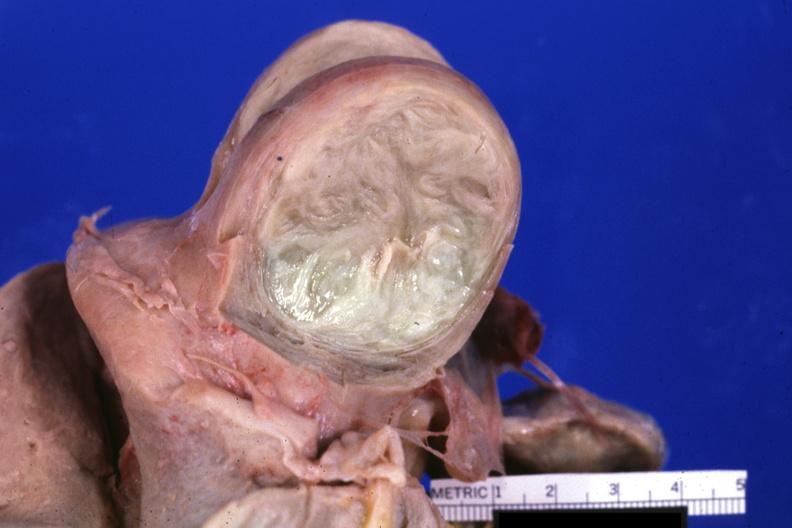what cut surface of typical myoma?
Answer the question using a single word or phrase. Fixed tissue 